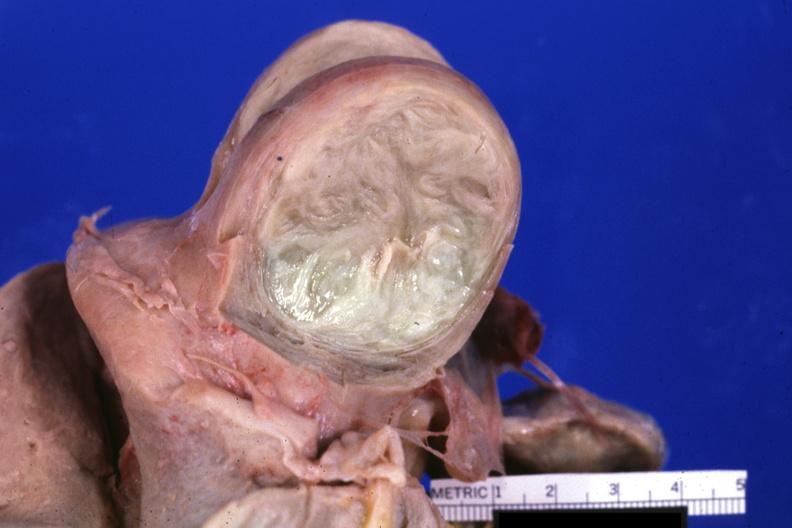what cut surface of typical myoma?
Answer the question using a single word or phrase. Fixed tissue 